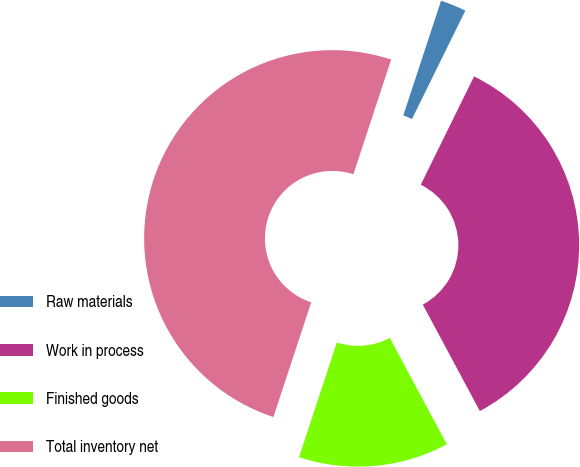Convert chart. <chart><loc_0><loc_0><loc_500><loc_500><pie_chart><fcel>Raw materials<fcel>Work in process<fcel>Finished goods<fcel>Total inventory net<nl><fcel>2.22%<fcel>34.89%<fcel>12.9%<fcel>50.0%<nl></chart> 